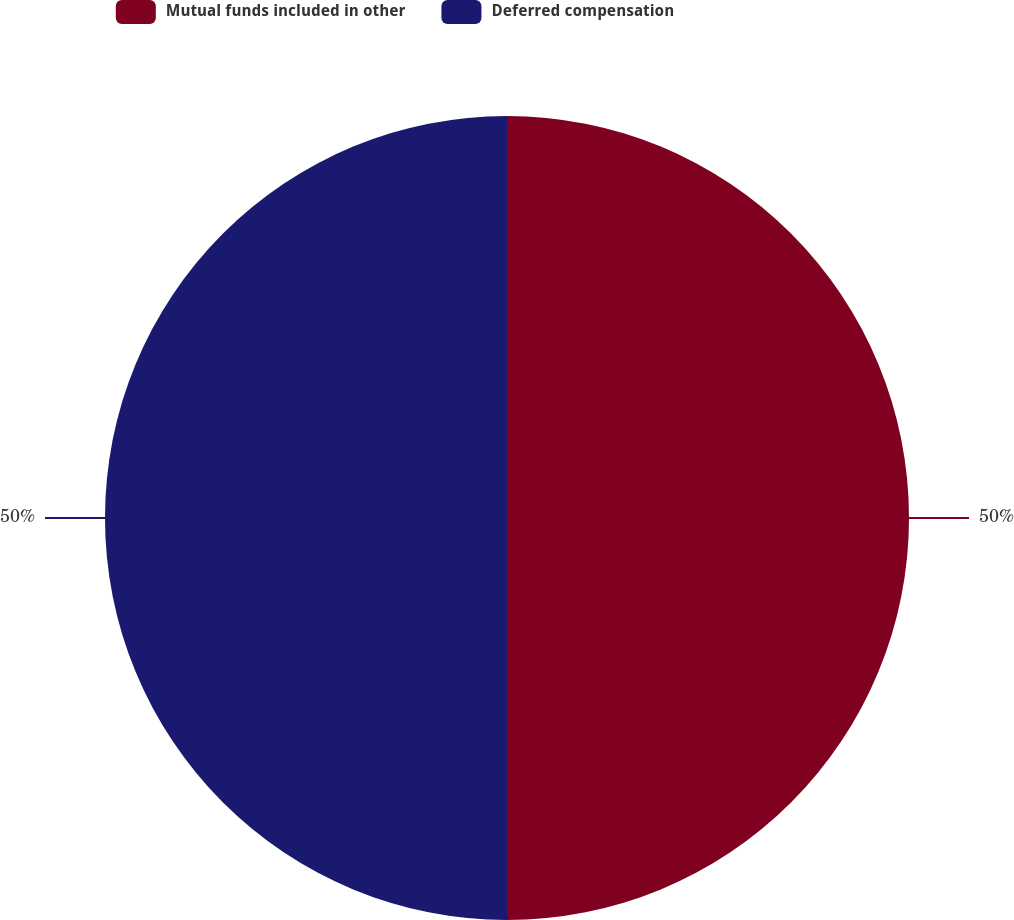Convert chart. <chart><loc_0><loc_0><loc_500><loc_500><pie_chart><fcel>Mutual funds included in other<fcel>Deferred compensation<nl><fcel>50.0%<fcel>50.0%<nl></chart> 